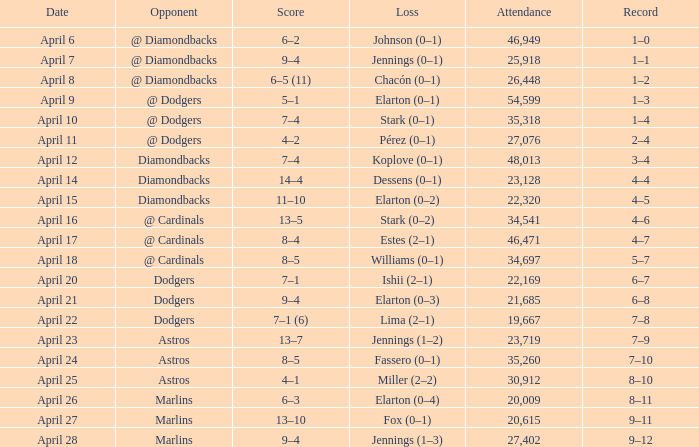Name the score when the opponent was the dodgers on april 21 9–4. Parse the full table. {'header': ['Date', 'Opponent', 'Score', 'Loss', 'Attendance', 'Record'], 'rows': [['April 6', '@ Diamondbacks', '6–2', 'Johnson (0–1)', '46,949', '1–0'], ['April 7', '@ Diamondbacks', '9–4', 'Jennings (0–1)', '25,918', '1–1'], ['April 8', '@ Diamondbacks', '6–5 (11)', 'Chacón (0–1)', '26,448', '1–2'], ['April 9', '@ Dodgers', '5–1', 'Elarton (0–1)', '54,599', '1–3'], ['April 10', '@ Dodgers', '7–4', 'Stark (0–1)', '35,318', '1–4'], ['April 11', '@ Dodgers', '4–2', 'Pérez (0–1)', '27,076', '2–4'], ['April 12', 'Diamondbacks', '7–4', 'Koplove (0–1)', '48,013', '3–4'], ['April 14', 'Diamondbacks', '14–4', 'Dessens (0–1)', '23,128', '4–4'], ['April 15', 'Diamondbacks', '11–10', 'Elarton (0–2)', '22,320', '4–5'], ['April 16', '@ Cardinals', '13–5', 'Stark (0–2)', '34,541', '4–6'], ['April 17', '@ Cardinals', '8–4', 'Estes (2–1)', '46,471', '4–7'], ['April 18', '@ Cardinals', '8–5', 'Williams (0–1)', '34,697', '5–7'], ['April 20', 'Dodgers', '7–1', 'Ishii (2–1)', '22,169', '6–7'], ['April 21', 'Dodgers', '9–4', 'Elarton (0–3)', '21,685', '6–8'], ['April 22', 'Dodgers', '7–1 (6)', 'Lima (2–1)', '19,667', '7–8'], ['April 23', 'Astros', '13–7', 'Jennings (1–2)', '23,719', '7–9'], ['April 24', 'Astros', '8–5', 'Fassero (0–1)', '35,260', '7–10'], ['April 25', 'Astros', '4–1', 'Miller (2–2)', '30,912', '8–10'], ['April 26', 'Marlins', '6–3', 'Elarton (0–4)', '20,009', '8–11'], ['April 27', 'Marlins', '13–10', 'Fox (0–1)', '20,615', '9–11'], ['April 28', 'Marlins', '9–4', 'Jennings (1–3)', '27,402', '9–12']]} 